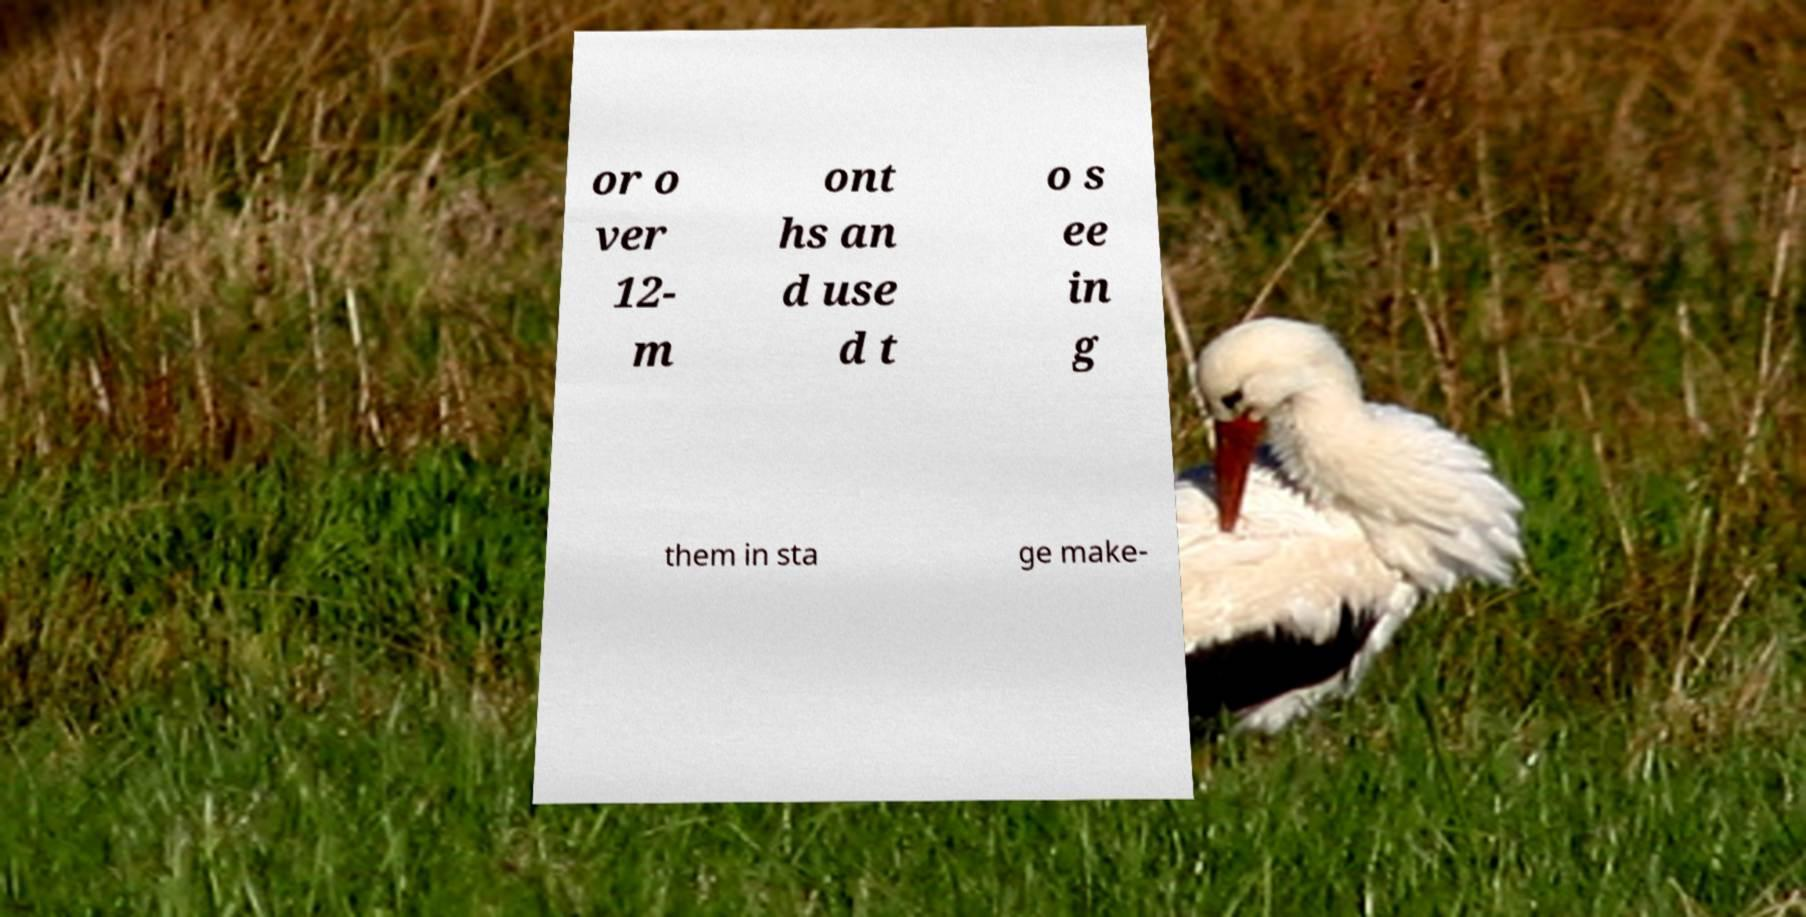Can you accurately transcribe the text from the provided image for me? or o ver 12- m ont hs an d use d t o s ee in g them in sta ge make- 